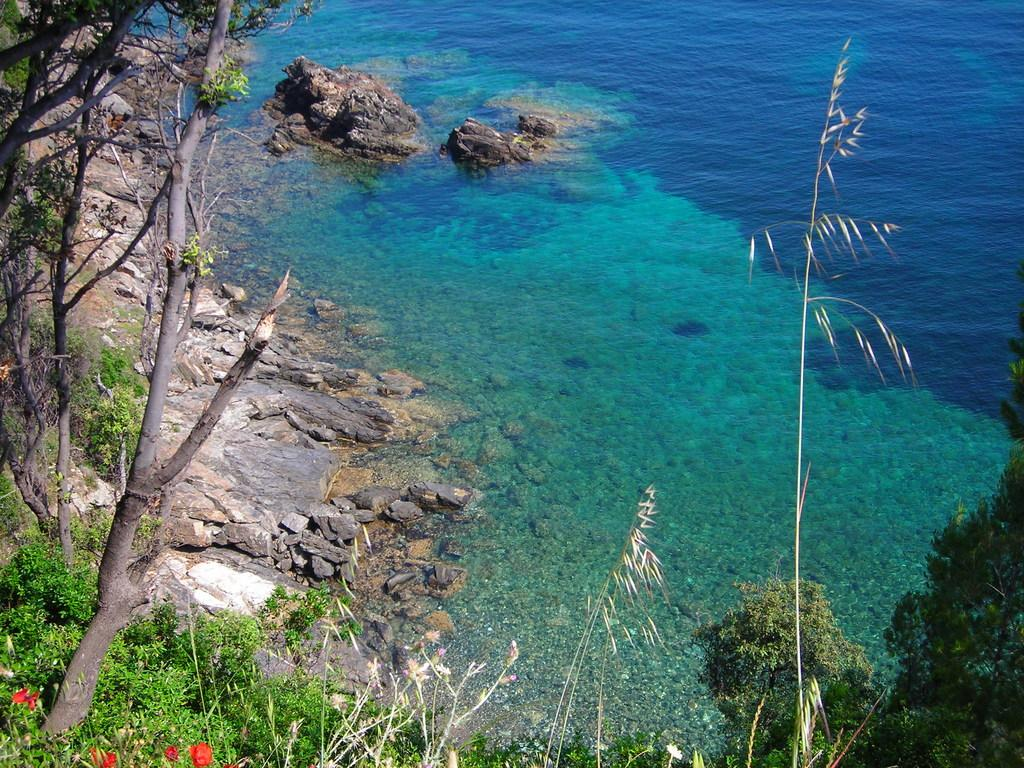What type of vegetation is on the left side of the image? There are trees on the left side of the image. What can be seen at the bottom of the image? There are flowers at the bottom of the image. What is visible in the background of the image? Water and stones are visible in the background of the image. Can you see a bubble floating near the flowers in the image? There is no bubble present in the image. Is there a head visible among the trees in the image? There is no head visible among the trees in the image. 